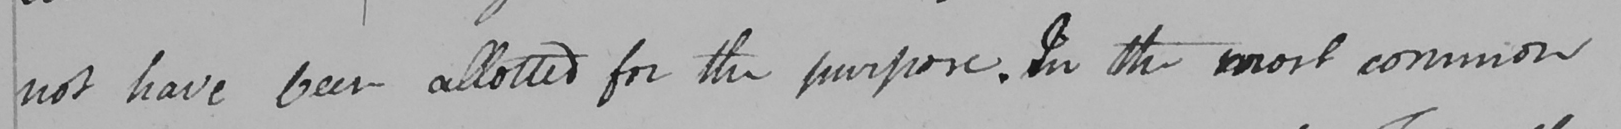Can you tell me what this handwritten text says? not have been allotted for the purpose . In the most common 